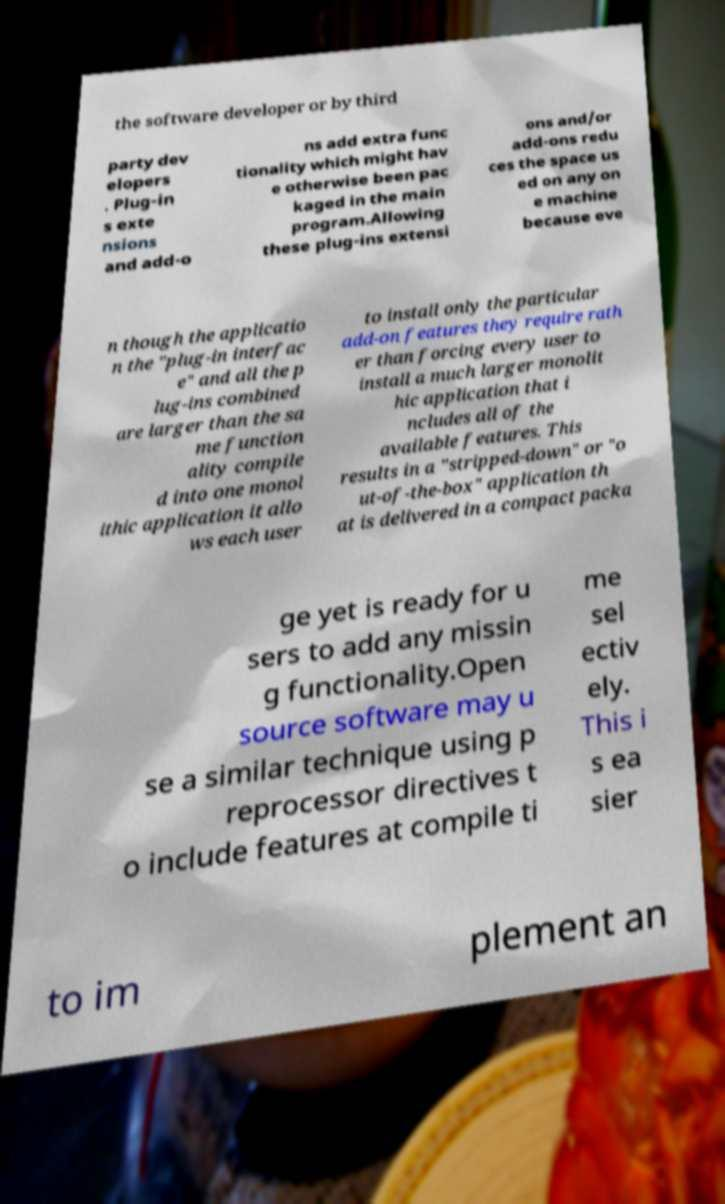There's text embedded in this image that I need extracted. Can you transcribe it verbatim? the software developer or by third party dev elopers . Plug-in s exte nsions and add-o ns add extra func tionality which might hav e otherwise been pac kaged in the main program.Allowing these plug-ins extensi ons and/or add-ons redu ces the space us ed on any on e machine because eve n though the applicatio n the "plug-in interfac e" and all the p lug-ins combined are larger than the sa me function ality compile d into one monol ithic application it allo ws each user to install only the particular add-on features they require rath er than forcing every user to install a much larger monolit hic application that i ncludes all of the available features. This results in a "stripped-down" or "o ut-of-the-box" application th at is delivered in a compact packa ge yet is ready for u sers to add any missin g functionality.Open source software may u se a similar technique using p reprocessor directives t o include features at compile ti me sel ectiv ely. This i s ea sier to im plement an 